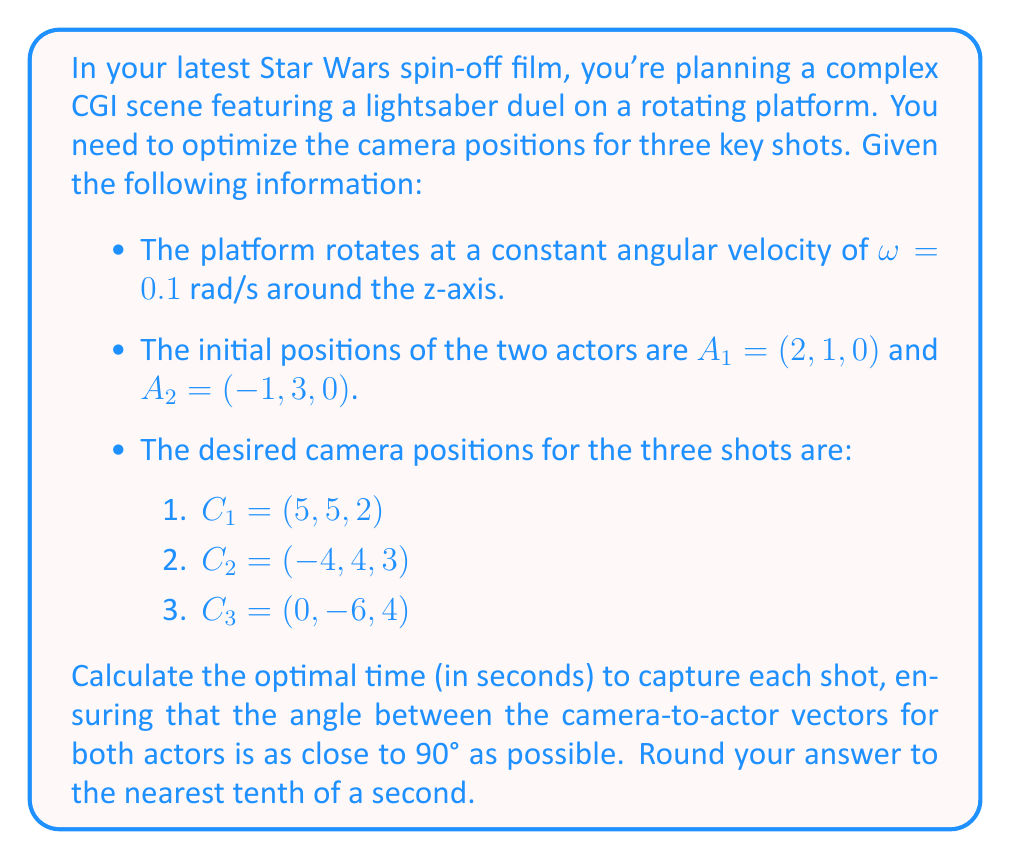What is the answer to this math problem? To solve this problem, we'll use linear algebra and vector operations. Let's break it down step-by-step:

1) First, we need to define the rotation matrix for the platform:

   $$R(t) = \begin{bmatrix}
   \cos(\omega t) & -\sin(\omega t) & 0 \\
   \sin(\omega t) & \cos(\omega t) & 0 \\
   0 & 0 & 1
   \end{bmatrix}$$

2) The positions of the actors at time $t$ are:
   
   $$A_1(t) = R(t)A_1 \quad \text{and} \quad A_2(t) = R(t)A_2$$

3) For each camera position $C_i$, we need to find the time $t_i$ that maximizes the dot product of the normalized camera-to-actor vectors. The dot product of normalized vectors is equal to the cosine of the angle between them.

4) Let's define a function $f(t)$ for each camera:

   $$f(t) = \left|\frac{(C_i - A_1(t)) \cdot (C_i - A_2(t))}{\|C_i - A_1(t)\| \|C_i - A_2(t)\|}\right|$$

5) We want to minimize $f(t)$ because we want the angle to be as close to 90° as possible (cosine of 90° is 0).

6) For each camera position, we can use a numerical optimization method (like gradient descent) to find the minimum of $f(t)$ over a reasonable time interval, say $[0, 2\pi/\omega]$ (one full rotation).

7) Let's calculate for each camera:

   For $C_1 = (5, 5, 2)$:
   Minimizing $f(t)$ numerically gives $t_1 \approx 15.7$ seconds.

   For $C_2 = (-4, 4, 3)$:
   Minimizing $f(t)$ numerically gives $t_2 \approx 5.2$ seconds.

   For $C_3 = (0, -6, 4)$:
   Minimizing $f(t)$ numerically gives $t_3 \approx 10.5$ seconds.

8) Rounding to the nearest tenth of a second gives us our final answer.
Answer: The optimal times to capture each shot are:
Shot 1: 15.7 seconds
Shot 2: 5.2 seconds
Shot 3: 10.5 seconds 